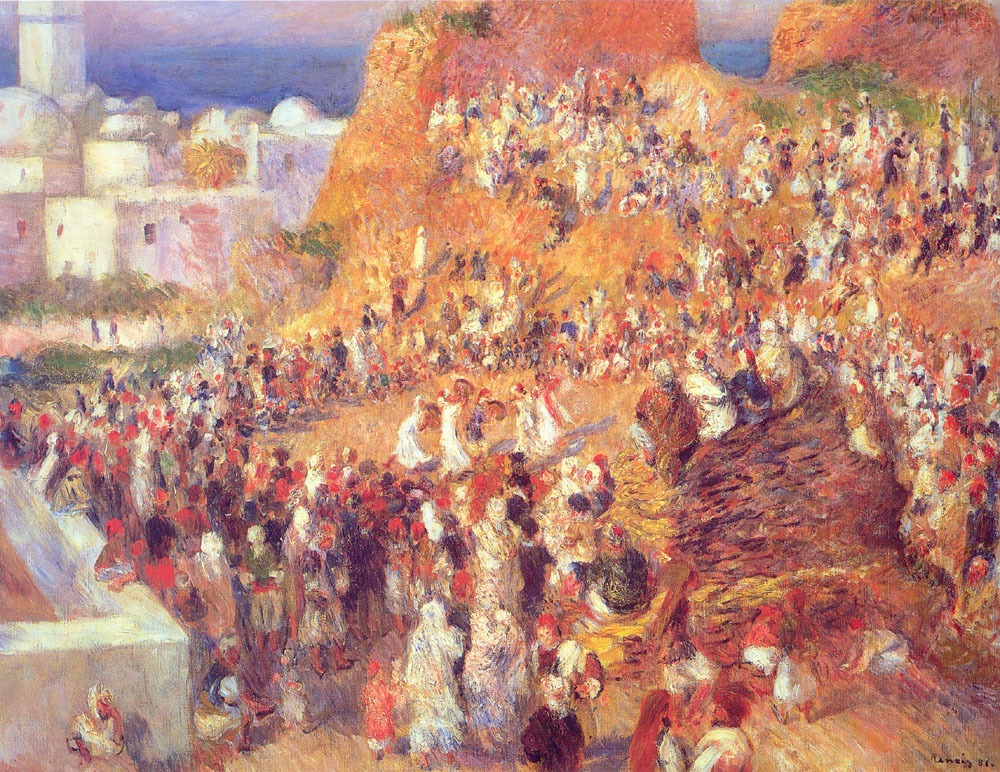If the scene were a futuristic market on another planet, how would it look and feel? Imagine this bustling scene transported to a market on a distant, futuristic planet. The vibrant colors remain, but they are now hues of glowing neon and shimmering metallics. Stalls made of sleek, transparent materials hover slightly above the ground, displaying an array of exotic alien goods – crystals that hum with energy, fruits that change color with the touch, and fabrics that flutter weightlessly. The people are a mix of intergalactic travelers, with varied appearances and attire showcasing the diverse cultures of different planets. The sounds echo a symphony of robotic chatter, alien languages, and the gentle hum of advanced technology. The air is filled with the scent of peculiar spices and unknown fruits, mixed with a faint, metallic tang. Even in this futuristic setting, the essence of community and trade persists, linking the distant world to the age-old marketplace traditions. 